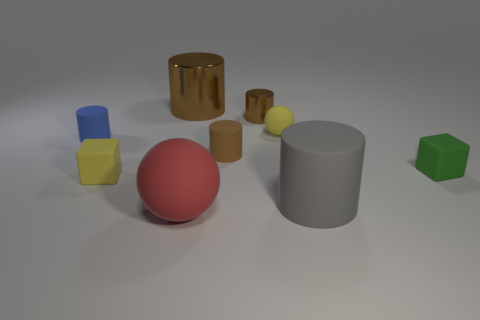What color is the large metallic object that is the same shape as the tiny metal thing?
Ensure brevity in your answer.  Brown. What color is the cube that is to the left of the rubber sphere that is in front of the blue object?
Give a very brief answer. Yellow. There is a brown rubber object that is the same shape as the blue object; what size is it?
Provide a short and direct response. Small. How many yellow objects have the same material as the small blue cylinder?
Make the answer very short. 2. How many blue objects are to the left of the yellow object right of the big red matte ball?
Your answer should be very brief. 1. Are there any big gray matte cylinders on the left side of the gray cylinder?
Make the answer very short. No. There is a big matte thing in front of the large gray cylinder; is its shape the same as the green rubber thing?
Make the answer very short. No. There is a tiny thing that is the same color as the small matte sphere; what is it made of?
Ensure brevity in your answer.  Rubber. How many rubber cylinders are the same color as the big metallic cylinder?
Give a very brief answer. 1. What is the shape of the tiny yellow thing that is to the right of the small yellow thing that is in front of the tiny green matte thing?
Your response must be concise. Sphere. 